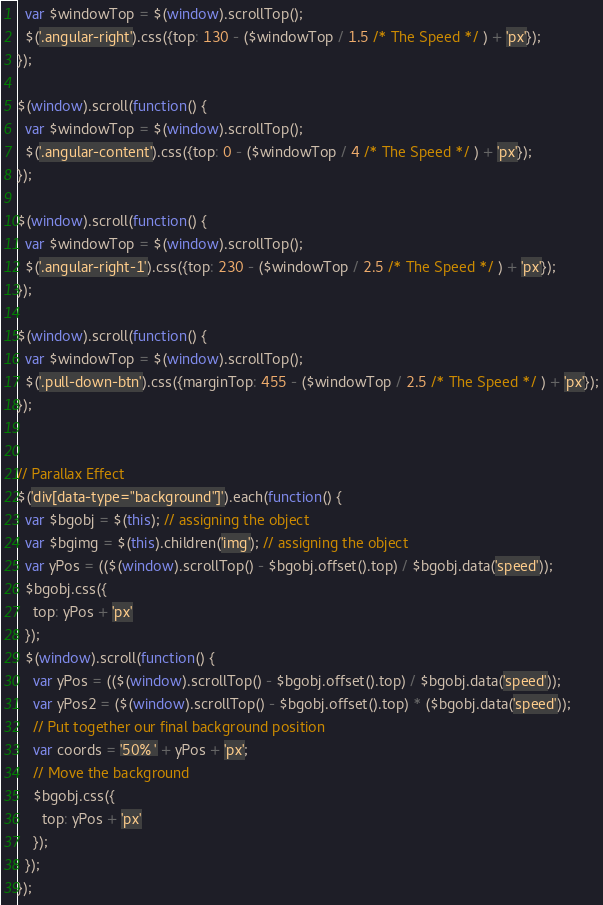<code> <loc_0><loc_0><loc_500><loc_500><_JavaScript_>  var $windowTop = $(window).scrollTop();
  $('.angular-right').css({top: 130 - ($windowTop / 1.5 /* The Speed */ ) + 'px'});
});

$(window).scroll(function() {
  var $windowTop = $(window).scrollTop();
  $('.angular-content').css({top: 0 - ($windowTop / 4 /* The Speed */ ) + 'px'});
});

$(window).scroll(function() {
  var $windowTop = $(window).scrollTop();
  $('.angular-right-1').css({top: 230 - ($windowTop / 2.5 /* The Speed */ ) + 'px'});
});

$(window).scroll(function() {
  var $windowTop = $(window).scrollTop();
  $('.pull-down-btn').css({marginTop: 455 - ($windowTop / 2.5 /* The Speed */ ) + 'px'});
});


// Parallax Effect
$('div[data-type="background"]').each(function() {
  var $bgobj = $(this); // assigning the object
  var $bgimg = $(this).children('img'); // assigning the object
  var yPos = (($(window).scrollTop() - $bgobj.offset().top) / $bgobj.data('speed'));
  $bgobj.css({
    top: yPos + 'px'
  });
  $(window).scroll(function() {
    var yPos = (($(window).scrollTop() - $bgobj.offset().top) / $bgobj.data('speed'));
    var yPos2 = ($(window).scrollTop() - $bgobj.offset().top) * ($bgobj.data('speed'));
    // Put together our final background position
    var coords = '50% ' + yPos + 'px';
    // Move the background
    $bgobj.css({
      top: yPos + 'px'
    });
  });
});
</code> 